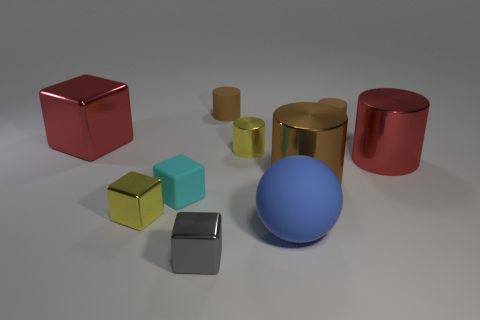How many brown cylinders must be subtracted to get 1 brown cylinders? 2 Subtract all small brown cylinders. How many cylinders are left? 3 Subtract all brown cylinders. How many cylinders are left? 2 Subtract all blocks. How many objects are left? 6 Subtract 3 blocks. How many blocks are left? 1 Add 1 tiny rubber cylinders. How many tiny rubber cylinders exist? 3 Subtract 0 green cubes. How many objects are left? 10 Subtract all yellow balls. Subtract all red cylinders. How many balls are left? 1 Subtract all brown cylinders. How many brown balls are left? 0 Subtract all large brown rubber cubes. Subtract all large matte objects. How many objects are left? 9 